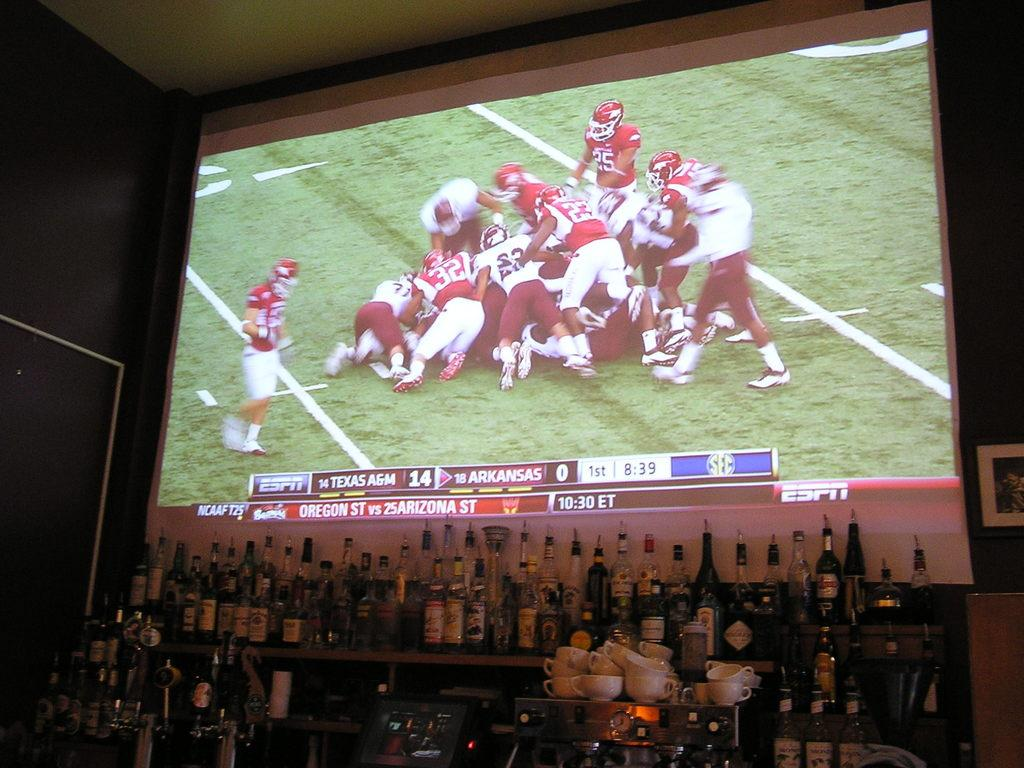What is the main feature in the image? There is a projector screen in the image. What objects are placed in front of the projector screen? There are bottles and cups in front of the projector screen. Can you describe the decoration on the wall beside the projector screen? There is a frame on the wall beside the projector screen. What type of letters are being displayed on the stage in the image? There is no stage or letters present in the image; it features a projector screen with bottles and cups in front of it, and a frame on the wall beside it. 